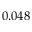Convert formula to latex. <formula><loc_0><loc_0><loc_500><loc_500>0 . 0 4 8</formula> 